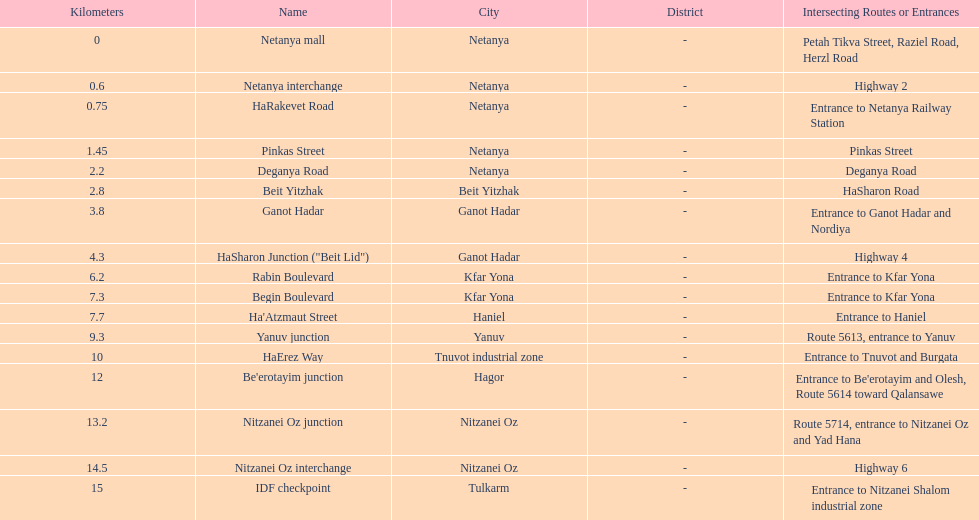Which location comes after kfar yona? Haniel. 